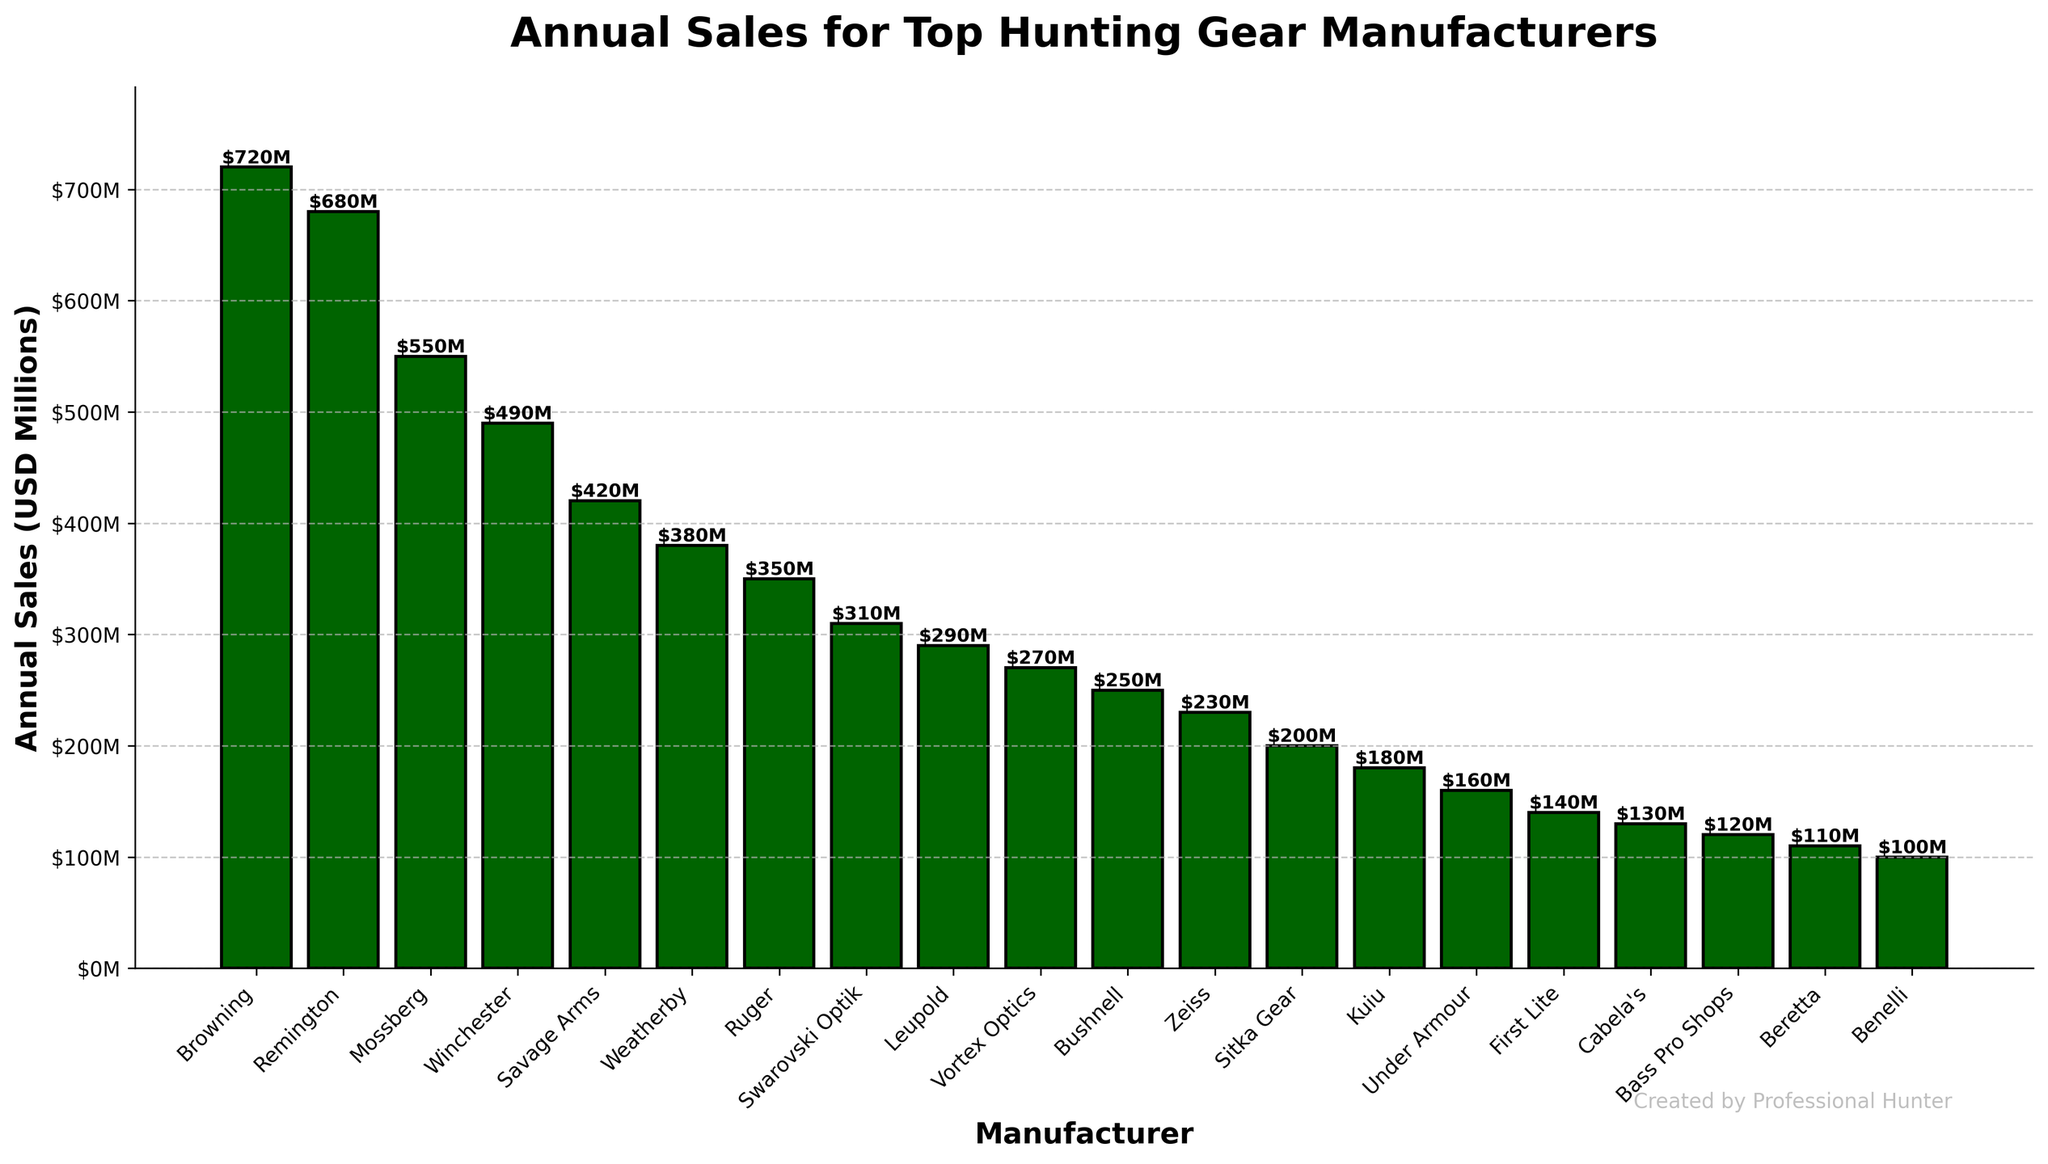What's the manufacturer with the highest annual sales? The bar that extends the highest on the chart is labeled "Browning." Therefore, Browning has the highest annual sales.
Answer: Browning What's the combined annual sales of Weatherby, Ruger, and Swarovski Optik? Sum the values of the bars labeled Weatherby (380M), Ruger (350M), and Swarovski Optik (310M): 380 + 350 + 310 = 1040
Answer: 1040M Which manufacturer has higher annual sales, Mossberg or Remington? Compare the heights of the bars labeled Mossberg (550M) and Remington (680M). Remington's bar is higher.
Answer: Remington What is the difference in annual sales between Leupold and Vortex Optics? Subtract the value of the bar labeled Vortex Optics (270M) from the value of the bar labeled Leupold (290M): 290 - 270 = 20
Answer: 20M How does the annual sales of Cabela's compare to Benelli? Cabela's has annual sales of 130M and Benelli has 100M. Compare their two bars, the bar for Cabela's is higher than Benelli's.
Answer: Cabela's has higher annual sales What's the total annual sales of the top three manufacturers? Sum the values of the top three manufacturers: Browning (720M), Remington (680M), and Mossberg (550M): 720 + 680 + 550 = 1950
Answer: 1950M Which manufacturers have annual sales less than 200M? Check the bars with heights less than 200M: Kuiu (180M), Under Armour (160M), First Lite (140M), Cabela's (130M), Bass Pro Shops (120M), Beretta (110M), and Benelli (100M).
Answer: Kuiu, Under Armour, First Lite, Cabela's, Bass Pro Shops, Beretta, Benelli What's the average annual sales of the four manufacturers with the lowest sales? Calculate the average of the lowest four values: Benelli (100M), Beretta (110M), Bass Pro Shops (120M), and Cabela's (130M). The sum is 460, and there are 4 values, so 460 / 4 = 115
Answer: 115M Which manufacturers have annual sales between 200M and 300M? Identify the bars falling within this range: Swarovski Optik (310M), Leupold (290M), Vortex Optics (270M), and Bushnell (250M). Only bars for Vortex Optics (270M) and Bushnell (250M) fall within the range exactly.
Answer: Vortex Optics, Bushnell 